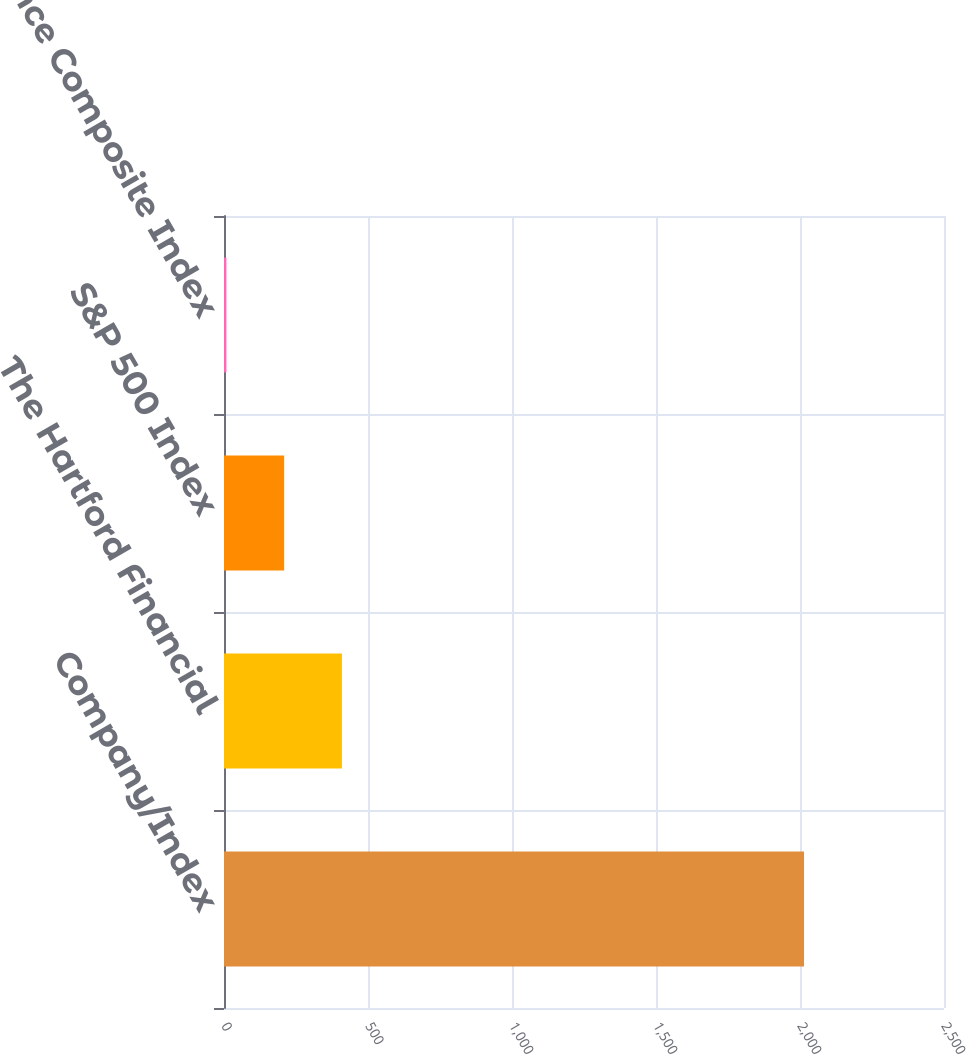Convert chart. <chart><loc_0><loc_0><loc_500><loc_500><bar_chart><fcel>Company/Index<fcel>The Hartford Financial<fcel>S&P 500 Index<fcel>S&P Insurance Composite Index<nl><fcel>2014<fcel>409.43<fcel>208.86<fcel>8.29<nl></chart> 